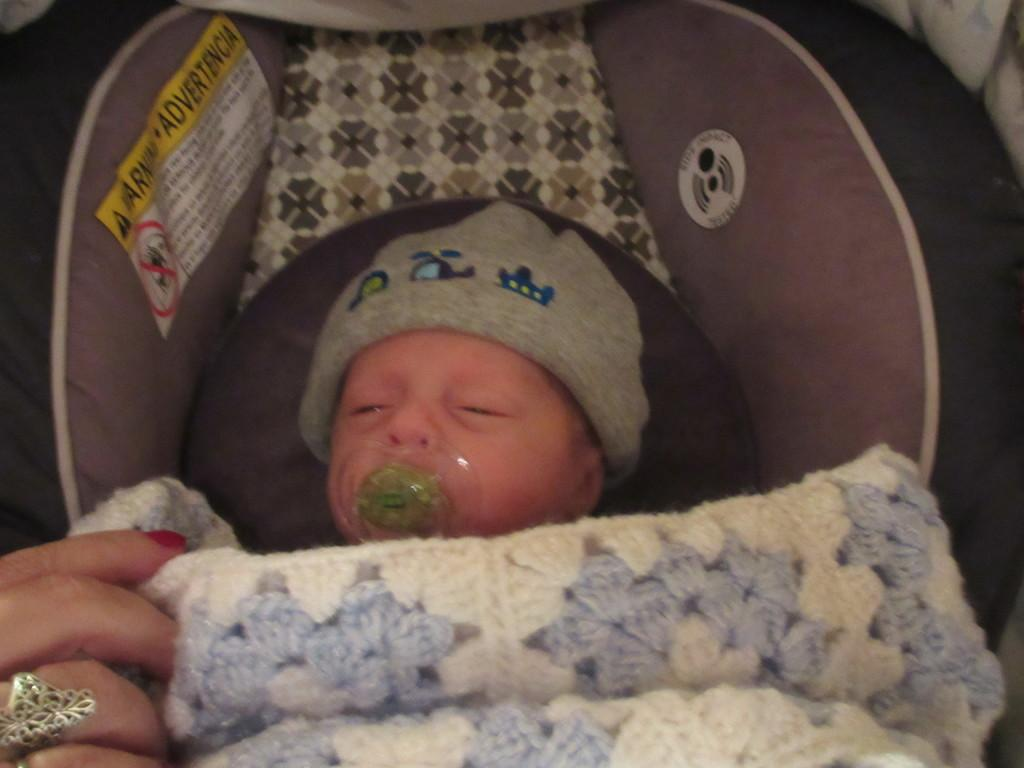What is the main subject of the image? There is a baby in the image. What is the baby doing in the image? The baby is sleeping. What is covering the baby in the image? There is a white cloth on the baby. Can you see any part of a person in the image? Yes, a human hand is visible in the image. What type of smile can be seen on the baby's face in the image? The baby is sleeping, so there is no smile visible on the baby's face in the image. Can you tell me how many chess pieces are on the table next to the baby? There is no table or chess pieces present in the image; it only features a baby sleeping with a white cloth and a visible human hand. 